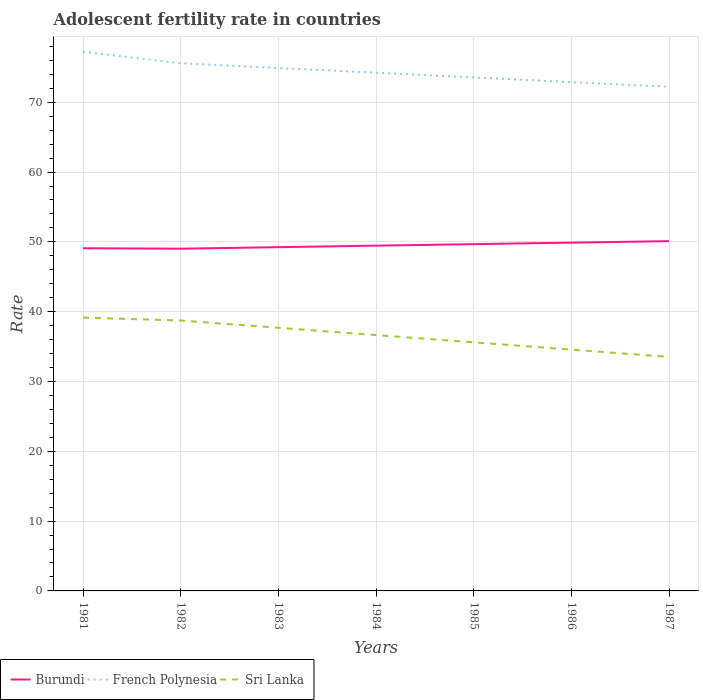How many different coloured lines are there?
Your answer should be compact. 3. Does the line corresponding to Sri Lanka intersect with the line corresponding to French Polynesia?
Offer a very short reply. No. Across all years, what is the maximum adolescent fertility rate in Burundi?
Your answer should be compact. 49.02. In which year was the adolescent fertility rate in French Polynesia maximum?
Make the answer very short. 1987. What is the total adolescent fertility rate in Burundi in the graph?
Provide a succinct answer. -1.08. What is the difference between the highest and the second highest adolescent fertility rate in Sri Lanka?
Your answer should be compact. 5.63. Is the adolescent fertility rate in Burundi strictly greater than the adolescent fertility rate in Sri Lanka over the years?
Make the answer very short. No. What is the difference between two consecutive major ticks on the Y-axis?
Your answer should be very brief. 10. How many legend labels are there?
Make the answer very short. 3. What is the title of the graph?
Ensure brevity in your answer.  Adolescent fertility rate in countries. Does "Uruguay" appear as one of the legend labels in the graph?
Provide a succinct answer. No. What is the label or title of the X-axis?
Provide a short and direct response. Years. What is the label or title of the Y-axis?
Offer a very short reply. Rate. What is the Rate of Burundi in 1981?
Offer a very short reply. 49.09. What is the Rate of French Polynesia in 1981?
Keep it short and to the point. 77.22. What is the Rate in Sri Lanka in 1981?
Ensure brevity in your answer.  39.15. What is the Rate of Burundi in 1982?
Keep it short and to the point. 49.02. What is the Rate of French Polynesia in 1982?
Make the answer very short. 75.58. What is the Rate in Sri Lanka in 1982?
Keep it short and to the point. 38.74. What is the Rate in Burundi in 1983?
Your answer should be compact. 49.24. What is the Rate in French Polynesia in 1983?
Offer a terse response. 74.91. What is the Rate in Sri Lanka in 1983?
Keep it short and to the point. 37.69. What is the Rate of Burundi in 1984?
Ensure brevity in your answer.  49.46. What is the Rate in French Polynesia in 1984?
Offer a very short reply. 74.23. What is the Rate in Sri Lanka in 1984?
Give a very brief answer. 36.65. What is the Rate of Burundi in 1985?
Make the answer very short. 49.67. What is the Rate in French Polynesia in 1985?
Ensure brevity in your answer.  73.56. What is the Rate of Sri Lanka in 1985?
Keep it short and to the point. 35.61. What is the Rate in Burundi in 1986?
Your answer should be compact. 49.89. What is the Rate of French Polynesia in 1986?
Make the answer very short. 72.88. What is the Rate in Sri Lanka in 1986?
Your response must be concise. 34.56. What is the Rate in Burundi in 1987?
Ensure brevity in your answer.  50.11. What is the Rate in French Polynesia in 1987?
Give a very brief answer. 72.21. What is the Rate in Sri Lanka in 1987?
Make the answer very short. 33.52. Across all years, what is the maximum Rate of Burundi?
Provide a short and direct response. 50.11. Across all years, what is the maximum Rate in French Polynesia?
Provide a succinct answer. 77.22. Across all years, what is the maximum Rate in Sri Lanka?
Your answer should be compact. 39.15. Across all years, what is the minimum Rate of Burundi?
Provide a short and direct response. 49.02. Across all years, what is the minimum Rate in French Polynesia?
Ensure brevity in your answer.  72.21. Across all years, what is the minimum Rate in Sri Lanka?
Your answer should be very brief. 33.52. What is the total Rate in Burundi in the graph?
Keep it short and to the point. 346.48. What is the total Rate in French Polynesia in the graph?
Give a very brief answer. 520.59. What is the total Rate of Sri Lanka in the graph?
Make the answer very short. 255.93. What is the difference between the Rate in Burundi in 1981 and that in 1982?
Your answer should be very brief. 0.06. What is the difference between the Rate of French Polynesia in 1981 and that in 1982?
Your answer should be very brief. 1.64. What is the difference between the Rate in Sri Lanka in 1981 and that in 1982?
Your answer should be very brief. 0.41. What is the difference between the Rate in Burundi in 1981 and that in 1983?
Offer a very short reply. -0.15. What is the difference between the Rate of French Polynesia in 1981 and that in 1983?
Ensure brevity in your answer.  2.32. What is the difference between the Rate in Sri Lanka in 1981 and that in 1983?
Keep it short and to the point. 1.46. What is the difference between the Rate in Burundi in 1981 and that in 1984?
Provide a succinct answer. -0.37. What is the difference between the Rate in French Polynesia in 1981 and that in 1984?
Provide a succinct answer. 2.99. What is the difference between the Rate in Sri Lanka in 1981 and that in 1984?
Your answer should be very brief. 2.5. What is the difference between the Rate of Burundi in 1981 and that in 1985?
Make the answer very short. -0.59. What is the difference between the Rate of French Polynesia in 1981 and that in 1985?
Make the answer very short. 3.66. What is the difference between the Rate of Sri Lanka in 1981 and that in 1985?
Give a very brief answer. 3.54. What is the difference between the Rate of Burundi in 1981 and that in 1986?
Make the answer very short. -0.8. What is the difference between the Rate in French Polynesia in 1981 and that in 1986?
Your response must be concise. 4.34. What is the difference between the Rate in Sri Lanka in 1981 and that in 1986?
Offer a very short reply. 4.59. What is the difference between the Rate in Burundi in 1981 and that in 1987?
Offer a very short reply. -1.02. What is the difference between the Rate in French Polynesia in 1981 and that in 1987?
Keep it short and to the point. 5.01. What is the difference between the Rate in Sri Lanka in 1981 and that in 1987?
Your response must be concise. 5.63. What is the difference between the Rate in Burundi in 1982 and that in 1983?
Offer a terse response. -0.22. What is the difference between the Rate in French Polynesia in 1982 and that in 1983?
Ensure brevity in your answer.  0.67. What is the difference between the Rate in Sri Lanka in 1982 and that in 1983?
Your answer should be very brief. 1.04. What is the difference between the Rate in Burundi in 1982 and that in 1984?
Make the answer very short. -0.43. What is the difference between the Rate in French Polynesia in 1982 and that in 1984?
Provide a succinct answer. 1.35. What is the difference between the Rate of Sri Lanka in 1982 and that in 1984?
Make the answer very short. 2.09. What is the difference between the Rate in Burundi in 1982 and that in 1985?
Ensure brevity in your answer.  -0.65. What is the difference between the Rate of French Polynesia in 1982 and that in 1985?
Your answer should be compact. 2.02. What is the difference between the Rate in Sri Lanka in 1982 and that in 1985?
Give a very brief answer. 3.13. What is the difference between the Rate of Burundi in 1982 and that in 1986?
Give a very brief answer. -0.87. What is the difference between the Rate of French Polynesia in 1982 and that in 1986?
Give a very brief answer. 2.7. What is the difference between the Rate of Sri Lanka in 1982 and that in 1986?
Give a very brief answer. 4.17. What is the difference between the Rate in Burundi in 1982 and that in 1987?
Give a very brief answer. -1.08. What is the difference between the Rate in French Polynesia in 1982 and that in 1987?
Your response must be concise. 3.37. What is the difference between the Rate in Sri Lanka in 1982 and that in 1987?
Offer a very short reply. 5.22. What is the difference between the Rate of Burundi in 1983 and that in 1984?
Give a very brief answer. -0.22. What is the difference between the Rate in French Polynesia in 1983 and that in 1984?
Give a very brief answer. 0.67. What is the difference between the Rate in Sri Lanka in 1983 and that in 1984?
Give a very brief answer. 1.04. What is the difference between the Rate of Burundi in 1983 and that in 1985?
Offer a terse response. -0.43. What is the difference between the Rate of French Polynesia in 1983 and that in 1985?
Your answer should be compact. 1.35. What is the difference between the Rate of Sri Lanka in 1983 and that in 1985?
Offer a very short reply. 2.09. What is the difference between the Rate in Burundi in 1983 and that in 1986?
Your answer should be very brief. -0.65. What is the difference between the Rate of French Polynesia in 1983 and that in 1986?
Your answer should be very brief. 2.02. What is the difference between the Rate of Sri Lanka in 1983 and that in 1986?
Provide a succinct answer. 3.13. What is the difference between the Rate in Burundi in 1983 and that in 1987?
Provide a short and direct response. -0.87. What is the difference between the Rate in French Polynesia in 1983 and that in 1987?
Your answer should be very brief. 2.7. What is the difference between the Rate of Sri Lanka in 1983 and that in 1987?
Provide a succinct answer. 4.17. What is the difference between the Rate of Burundi in 1984 and that in 1985?
Make the answer very short. -0.22. What is the difference between the Rate of French Polynesia in 1984 and that in 1985?
Provide a short and direct response. 0.67. What is the difference between the Rate of Sri Lanka in 1984 and that in 1985?
Your answer should be compact. 1.04. What is the difference between the Rate of Burundi in 1984 and that in 1986?
Your response must be concise. -0.43. What is the difference between the Rate in French Polynesia in 1984 and that in 1986?
Your answer should be very brief. 1.35. What is the difference between the Rate in Sri Lanka in 1984 and that in 1986?
Provide a short and direct response. 2.09. What is the difference between the Rate in Burundi in 1984 and that in 1987?
Your answer should be very brief. -0.65. What is the difference between the Rate of French Polynesia in 1984 and that in 1987?
Keep it short and to the point. 2.02. What is the difference between the Rate of Sri Lanka in 1984 and that in 1987?
Your answer should be very brief. 3.13. What is the difference between the Rate of Burundi in 1985 and that in 1986?
Offer a terse response. -0.22. What is the difference between the Rate of French Polynesia in 1985 and that in 1986?
Provide a succinct answer. 0.67. What is the difference between the Rate in Sri Lanka in 1985 and that in 1986?
Provide a short and direct response. 1.04. What is the difference between the Rate of Burundi in 1985 and that in 1987?
Give a very brief answer. -0.43. What is the difference between the Rate of French Polynesia in 1985 and that in 1987?
Ensure brevity in your answer.  1.35. What is the difference between the Rate in Sri Lanka in 1985 and that in 1987?
Make the answer very short. 2.09. What is the difference between the Rate in Burundi in 1986 and that in 1987?
Keep it short and to the point. -0.22. What is the difference between the Rate in French Polynesia in 1986 and that in 1987?
Make the answer very short. 0.67. What is the difference between the Rate of Sri Lanka in 1986 and that in 1987?
Give a very brief answer. 1.04. What is the difference between the Rate of Burundi in 1981 and the Rate of French Polynesia in 1982?
Provide a succinct answer. -26.49. What is the difference between the Rate in Burundi in 1981 and the Rate in Sri Lanka in 1982?
Your response must be concise. 10.35. What is the difference between the Rate of French Polynesia in 1981 and the Rate of Sri Lanka in 1982?
Offer a very short reply. 38.48. What is the difference between the Rate of Burundi in 1981 and the Rate of French Polynesia in 1983?
Provide a succinct answer. -25.82. What is the difference between the Rate in Burundi in 1981 and the Rate in Sri Lanka in 1983?
Give a very brief answer. 11.39. What is the difference between the Rate of French Polynesia in 1981 and the Rate of Sri Lanka in 1983?
Keep it short and to the point. 39.53. What is the difference between the Rate in Burundi in 1981 and the Rate in French Polynesia in 1984?
Your answer should be very brief. -25.14. What is the difference between the Rate of Burundi in 1981 and the Rate of Sri Lanka in 1984?
Your answer should be very brief. 12.44. What is the difference between the Rate in French Polynesia in 1981 and the Rate in Sri Lanka in 1984?
Offer a terse response. 40.57. What is the difference between the Rate of Burundi in 1981 and the Rate of French Polynesia in 1985?
Offer a terse response. -24.47. What is the difference between the Rate of Burundi in 1981 and the Rate of Sri Lanka in 1985?
Make the answer very short. 13.48. What is the difference between the Rate of French Polynesia in 1981 and the Rate of Sri Lanka in 1985?
Your answer should be compact. 41.61. What is the difference between the Rate of Burundi in 1981 and the Rate of French Polynesia in 1986?
Your response must be concise. -23.79. What is the difference between the Rate of Burundi in 1981 and the Rate of Sri Lanka in 1986?
Keep it short and to the point. 14.52. What is the difference between the Rate of French Polynesia in 1981 and the Rate of Sri Lanka in 1986?
Give a very brief answer. 42.66. What is the difference between the Rate of Burundi in 1981 and the Rate of French Polynesia in 1987?
Keep it short and to the point. -23.12. What is the difference between the Rate of Burundi in 1981 and the Rate of Sri Lanka in 1987?
Provide a short and direct response. 15.57. What is the difference between the Rate of French Polynesia in 1981 and the Rate of Sri Lanka in 1987?
Ensure brevity in your answer.  43.7. What is the difference between the Rate in Burundi in 1982 and the Rate in French Polynesia in 1983?
Keep it short and to the point. -25.88. What is the difference between the Rate in Burundi in 1982 and the Rate in Sri Lanka in 1983?
Your response must be concise. 11.33. What is the difference between the Rate of French Polynesia in 1982 and the Rate of Sri Lanka in 1983?
Provide a short and direct response. 37.89. What is the difference between the Rate of Burundi in 1982 and the Rate of French Polynesia in 1984?
Keep it short and to the point. -25.21. What is the difference between the Rate of Burundi in 1982 and the Rate of Sri Lanka in 1984?
Provide a short and direct response. 12.37. What is the difference between the Rate of French Polynesia in 1982 and the Rate of Sri Lanka in 1984?
Give a very brief answer. 38.93. What is the difference between the Rate of Burundi in 1982 and the Rate of French Polynesia in 1985?
Ensure brevity in your answer.  -24.53. What is the difference between the Rate in Burundi in 1982 and the Rate in Sri Lanka in 1985?
Keep it short and to the point. 13.42. What is the difference between the Rate in French Polynesia in 1982 and the Rate in Sri Lanka in 1985?
Your answer should be compact. 39.97. What is the difference between the Rate in Burundi in 1982 and the Rate in French Polynesia in 1986?
Ensure brevity in your answer.  -23.86. What is the difference between the Rate of Burundi in 1982 and the Rate of Sri Lanka in 1986?
Offer a very short reply. 14.46. What is the difference between the Rate in French Polynesia in 1982 and the Rate in Sri Lanka in 1986?
Offer a very short reply. 41.02. What is the difference between the Rate in Burundi in 1982 and the Rate in French Polynesia in 1987?
Keep it short and to the point. -23.18. What is the difference between the Rate in Burundi in 1982 and the Rate in Sri Lanka in 1987?
Provide a short and direct response. 15.5. What is the difference between the Rate in French Polynesia in 1982 and the Rate in Sri Lanka in 1987?
Provide a succinct answer. 42.06. What is the difference between the Rate in Burundi in 1983 and the Rate in French Polynesia in 1984?
Make the answer very short. -24.99. What is the difference between the Rate in Burundi in 1983 and the Rate in Sri Lanka in 1984?
Offer a very short reply. 12.59. What is the difference between the Rate of French Polynesia in 1983 and the Rate of Sri Lanka in 1984?
Your response must be concise. 38.26. What is the difference between the Rate of Burundi in 1983 and the Rate of French Polynesia in 1985?
Your answer should be very brief. -24.32. What is the difference between the Rate of Burundi in 1983 and the Rate of Sri Lanka in 1985?
Offer a very short reply. 13.63. What is the difference between the Rate in French Polynesia in 1983 and the Rate in Sri Lanka in 1985?
Offer a terse response. 39.3. What is the difference between the Rate of Burundi in 1983 and the Rate of French Polynesia in 1986?
Ensure brevity in your answer.  -23.64. What is the difference between the Rate of Burundi in 1983 and the Rate of Sri Lanka in 1986?
Your answer should be very brief. 14.68. What is the difference between the Rate in French Polynesia in 1983 and the Rate in Sri Lanka in 1986?
Your answer should be very brief. 40.34. What is the difference between the Rate of Burundi in 1983 and the Rate of French Polynesia in 1987?
Ensure brevity in your answer.  -22.97. What is the difference between the Rate of Burundi in 1983 and the Rate of Sri Lanka in 1987?
Your answer should be compact. 15.72. What is the difference between the Rate of French Polynesia in 1983 and the Rate of Sri Lanka in 1987?
Your response must be concise. 41.39. What is the difference between the Rate in Burundi in 1984 and the Rate in French Polynesia in 1985?
Provide a succinct answer. -24.1. What is the difference between the Rate in Burundi in 1984 and the Rate in Sri Lanka in 1985?
Make the answer very short. 13.85. What is the difference between the Rate in French Polynesia in 1984 and the Rate in Sri Lanka in 1985?
Keep it short and to the point. 38.62. What is the difference between the Rate of Burundi in 1984 and the Rate of French Polynesia in 1986?
Give a very brief answer. -23.43. What is the difference between the Rate in Burundi in 1984 and the Rate in Sri Lanka in 1986?
Offer a terse response. 14.89. What is the difference between the Rate of French Polynesia in 1984 and the Rate of Sri Lanka in 1986?
Provide a short and direct response. 39.67. What is the difference between the Rate in Burundi in 1984 and the Rate in French Polynesia in 1987?
Your answer should be very brief. -22.75. What is the difference between the Rate of Burundi in 1984 and the Rate of Sri Lanka in 1987?
Keep it short and to the point. 15.94. What is the difference between the Rate in French Polynesia in 1984 and the Rate in Sri Lanka in 1987?
Make the answer very short. 40.71. What is the difference between the Rate in Burundi in 1985 and the Rate in French Polynesia in 1986?
Your answer should be compact. -23.21. What is the difference between the Rate in Burundi in 1985 and the Rate in Sri Lanka in 1986?
Your answer should be very brief. 15.11. What is the difference between the Rate in French Polynesia in 1985 and the Rate in Sri Lanka in 1986?
Your answer should be very brief. 38.99. What is the difference between the Rate of Burundi in 1985 and the Rate of French Polynesia in 1987?
Provide a short and direct response. -22.53. What is the difference between the Rate in Burundi in 1985 and the Rate in Sri Lanka in 1987?
Your response must be concise. 16.15. What is the difference between the Rate in French Polynesia in 1985 and the Rate in Sri Lanka in 1987?
Provide a short and direct response. 40.04. What is the difference between the Rate of Burundi in 1986 and the Rate of French Polynesia in 1987?
Provide a short and direct response. -22.32. What is the difference between the Rate of Burundi in 1986 and the Rate of Sri Lanka in 1987?
Your answer should be compact. 16.37. What is the difference between the Rate in French Polynesia in 1986 and the Rate in Sri Lanka in 1987?
Your answer should be very brief. 39.36. What is the average Rate in Burundi per year?
Offer a terse response. 49.5. What is the average Rate in French Polynesia per year?
Give a very brief answer. 74.37. What is the average Rate of Sri Lanka per year?
Offer a terse response. 36.56. In the year 1981, what is the difference between the Rate of Burundi and Rate of French Polynesia?
Your response must be concise. -28.13. In the year 1981, what is the difference between the Rate of Burundi and Rate of Sri Lanka?
Offer a very short reply. 9.94. In the year 1981, what is the difference between the Rate of French Polynesia and Rate of Sri Lanka?
Ensure brevity in your answer.  38.07. In the year 1982, what is the difference between the Rate in Burundi and Rate in French Polynesia?
Your response must be concise. -26.56. In the year 1982, what is the difference between the Rate of Burundi and Rate of Sri Lanka?
Provide a succinct answer. 10.29. In the year 1982, what is the difference between the Rate of French Polynesia and Rate of Sri Lanka?
Your response must be concise. 36.84. In the year 1983, what is the difference between the Rate in Burundi and Rate in French Polynesia?
Make the answer very short. -25.67. In the year 1983, what is the difference between the Rate in Burundi and Rate in Sri Lanka?
Provide a succinct answer. 11.55. In the year 1983, what is the difference between the Rate of French Polynesia and Rate of Sri Lanka?
Keep it short and to the point. 37.21. In the year 1984, what is the difference between the Rate in Burundi and Rate in French Polynesia?
Your answer should be very brief. -24.77. In the year 1984, what is the difference between the Rate of Burundi and Rate of Sri Lanka?
Provide a succinct answer. 12.81. In the year 1984, what is the difference between the Rate in French Polynesia and Rate in Sri Lanka?
Keep it short and to the point. 37.58. In the year 1985, what is the difference between the Rate in Burundi and Rate in French Polynesia?
Provide a succinct answer. -23.88. In the year 1985, what is the difference between the Rate of Burundi and Rate of Sri Lanka?
Your response must be concise. 14.07. In the year 1985, what is the difference between the Rate in French Polynesia and Rate in Sri Lanka?
Give a very brief answer. 37.95. In the year 1986, what is the difference between the Rate of Burundi and Rate of French Polynesia?
Offer a very short reply. -22.99. In the year 1986, what is the difference between the Rate of Burundi and Rate of Sri Lanka?
Give a very brief answer. 15.33. In the year 1986, what is the difference between the Rate in French Polynesia and Rate in Sri Lanka?
Make the answer very short. 38.32. In the year 1987, what is the difference between the Rate in Burundi and Rate in French Polynesia?
Make the answer very short. -22.1. In the year 1987, what is the difference between the Rate in Burundi and Rate in Sri Lanka?
Offer a terse response. 16.59. In the year 1987, what is the difference between the Rate of French Polynesia and Rate of Sri Lanka?
Your response must be concise. 38.69. What is the ratio of the Rate of Burundi in 1981 to that in 1982?
Your answer should be very brief. 1. What is the ratio of the Rate of French Polynesia in 1981 to that in 1982?
Give a very brief answer. 1.02. What is the ratio of the Rate of Sri Lanka in 1981 to that in 1982?
Ensure brevity in your answer.  1.01. What is the ratio of the Rate of Burundi in 1981 to that in 1983?
Provide a succinct answer. 1. What is the ratio of the Rate of French Polynesia in 1981 to that in 1983?
Make the answer very short. 1.03. What is the ratio of the Rate of Sri Lanka in 1981 to that in 1983?
Offer a very short reply. 1.04. What is the ratio of the Rate in Burundi in 1981 to that in 1984?
Your answer should be compact. 0.99. What is the ratio of the Rate in French Polynesia in 1981 to that in 1984?
Make the answer very short. 1.04. What is the ratio of the Rate of Sri Lanka in 1981 to that in 1984?
Provide a succinct answer. 1.07. What is the ratio of the Rate in Burundi in 1981 to that in 1985?
Ensure brevity in your answer.  0.99. What is the ratio of the Rate of French Polynesia in 1981 to that in 1985?
Your answer should be compact. 1.05. What is the ratio of the Rate in Sri Lanka in 1981 to that in 1985?
Provide a short and direct response. 1.1. What is the ratio of the Rate of Burundi in 1981 to that in 1986?
Your answer should be compact. 0.98. What is the ratio of the Rate in French Polynesia in 1981 to that in 1986?
Your answer should be compact. 1.06. What is the ratio of the Rate in Sri Lanka in 1981 to that in 1986?
Your answer should be very brief. 1.13. What is the ratio of the Rate of Burundi in 1981 to that in 1987?
Your answer should be compact. 0.98. What is the ratio of the Rate of French Polynesia in 1981 to that in 1987?
Your response must be concise. 1.07. What is the ratio of the Rate in Sri Lanka in 1981 to that in 1987?
Your answer should be very brief. 1.17. What is the ratio of the Rate of Burundi in 1982 to that in 1983?
Provide a succinct answer. 1. What is the ratio of the Rate of Sri Lanka in 1982 to that in 1983?
Offer a terse response. 1.03. What is the ratio of the Rate of French Polynesia in 1982 to that in 1984?
Ensure brevity in your answer.  1.02. What is the ratio of the Rate of Sri Lanka in 1982 to that in 1984?
Keep it short and to the point. 1.06. What is the ratio of the Rate of Burundi in 1982 to that in 1985?
Your response must be concise. 0.99. What is the ratio of the Rate in French Polynesia in 1982 to that in 1985?
Provide a short and direct response. 1.03. What is the ratio of the Rate of Sri Lanka in 1982 to that in 1985?
Keep it short and to the point. 1.09. What is the ratio of the Rate in Burundi in 1982 to that in 1986?
Ensure brevity in your answer.  0.98. What is the ratio of the Rate in French Polynesia in 1982 to that in 1986?
Your answer should be very brief. 1.04. What is the ratio of the Rate in Sri Lanka in 1982 to that in 1986?
Provide a short and direct response. 1.12. What is the ratio of the Rate in Burundi in 1982 to that in 1987?
Your answer should be compact. 0.98. What is the ratio of the Rate of French Polynesia in 1982 to that in 1987?
Make the answer very short. 1.05. What is the ratio of the Rate of Sri Lanka in 1982 to that in 1987?
Your response must be concise. 1.16. What is the ratio of the Rate of Burundi in 1983 to that in 1984?
Provide a short and direct response. 1. What is the ratio of the Rate of French Polynesia in 1983 to that in 1984?
Provide a succinct answer. 1.01. What is the ratio of the Rate of Sri Lanka in 1983 to that in 1984?
Your answer should be compact. 1.03. What is the ratio of the Rate of French Polynesia in 1983 to that in 1985?
Offer a very short reply. 1.02. What is the ratio of the Rate in Sri Lanka in 1983 to that in 1985?
Keep it short and to the point. 1.06. What is the ratio of the Rate of French Polynesia in 1983 to that in 1986?
Offer a terse response. 1.03. What is the ratio of the Rate of Sri Lanka in 1983 to that in 1986?
Make the answer very short. 1.09. What is the ratio of the Rate in Burundi in 1983 to that in 1987?
Give a very brief answer. 0.98. What is the ratio of the Rate in French Polynesia in 1983 to that in 1987?
Keep it short and to the point. 1.04. What is the ratio of the Rate of Sri Lanka in 1983 to that in 1987?
Keep it short and to the point. 1.12. What is the ratio of the Rate in French Polynesia in 1984 to that in 1985?
Keep it short and to the point. 1.01. What is the ratio of the Rate of Sri Lanka in 1984 to that in 1985?
Give a very brief answer. 1.03. What is the ratio of the Rate of French Polynesia in 1984 to that in 1986?
Give a very brief answer. 1.02. What is the ratio of the Rate of Sri Lanka in 1984 to that in 1986?
Your response must be concise. 1.06. What is the ratio of the Rate in Burundi in 1984 to that in 1987?
Provide a short and direct response. 0.99. What is the ratio of the Rate in French Polynesia in 1984 to that in 1987?
Offer a very short reply. 1.03. What is the ratio of the Rate of Sri Lanka in 1984 to that in 1987?
Your response must be concise. 1.09. What is the ratio of the Rate in Burundi in 1985 to that in 1986?
Your answer should be compact. 1. What is the ratio of the Rate in French Polynesia in 1985 to that in 1986?
Provide a succinct answer. 1.01. What is the ratio of the Rate of Sri Lanka in 1985 to that in 1986?
Offer a very short reply. 1.03. What is the ratio of the Rate in Burundi in 1985 to that in 1987?
Provide a short and direct response. 0.99. What is the ratio of the Rate in French Polynesia in 1985 to that in 1987?
Your answer should be compact. 1.02. What is the ratio of the Rate in Sri Lanka in 1985 to that in 1987?
Offer a terse response. 1.06. What is the ratio of the Rate in French Polynesia in 1986 to that in 1987?
Offer a very short reply. 1.01. What is the ratio of the Rate of Sri Lanka in 1986 to that in 1987?
Your answer should be compact. 1.03. What is the difference between the highest and the second highest Rate in Burundi?
Offer a very short reply. 0.22. What is the difference between the highest and the second highest Rate of French Polynesia?
Give a very brief answer. 1.64. What is the difference between the highest and the second highest Rate of Sri Lanka?
Ensure brevity in your answer.  0.41. What is the difference between the highest and the lowest Rate of Burundi?
Make the answer very short. 1.08. What is the difference between the highest and the lowest Rate of French Polynesia?
Provide a short and direct response. 5.01. What is the difference between the highest and the lowest Rate in Sri Lanka?
Give a very brief answer. 5.63. 